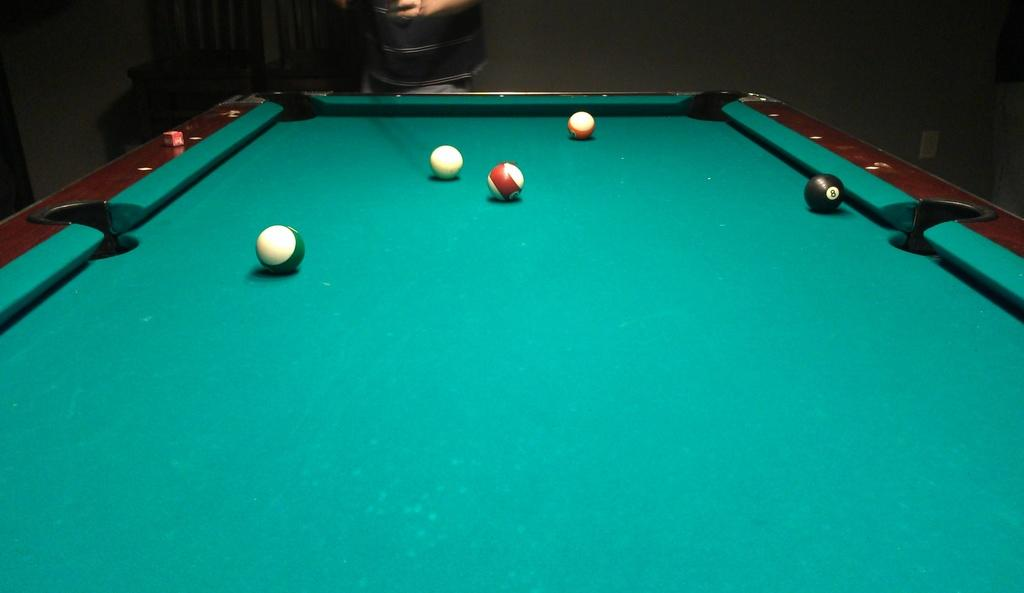What is the main object in the image? There is a board in the image. What is on the board? There are balls on the board. What game is being played on the board? The game is known as snookers. Who is present in the image? A person is standing in front of the board. How many lizards are crawling on the board in the image? There are no lizards present in the image; it features a board with balls for a game of snookers. 